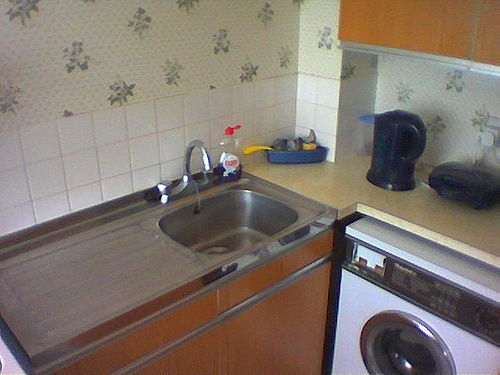Describe the objects in this image and their specific colors. I can see sink in gray and black tones and bottle in gray, darkgray, and navy tones in this image. 